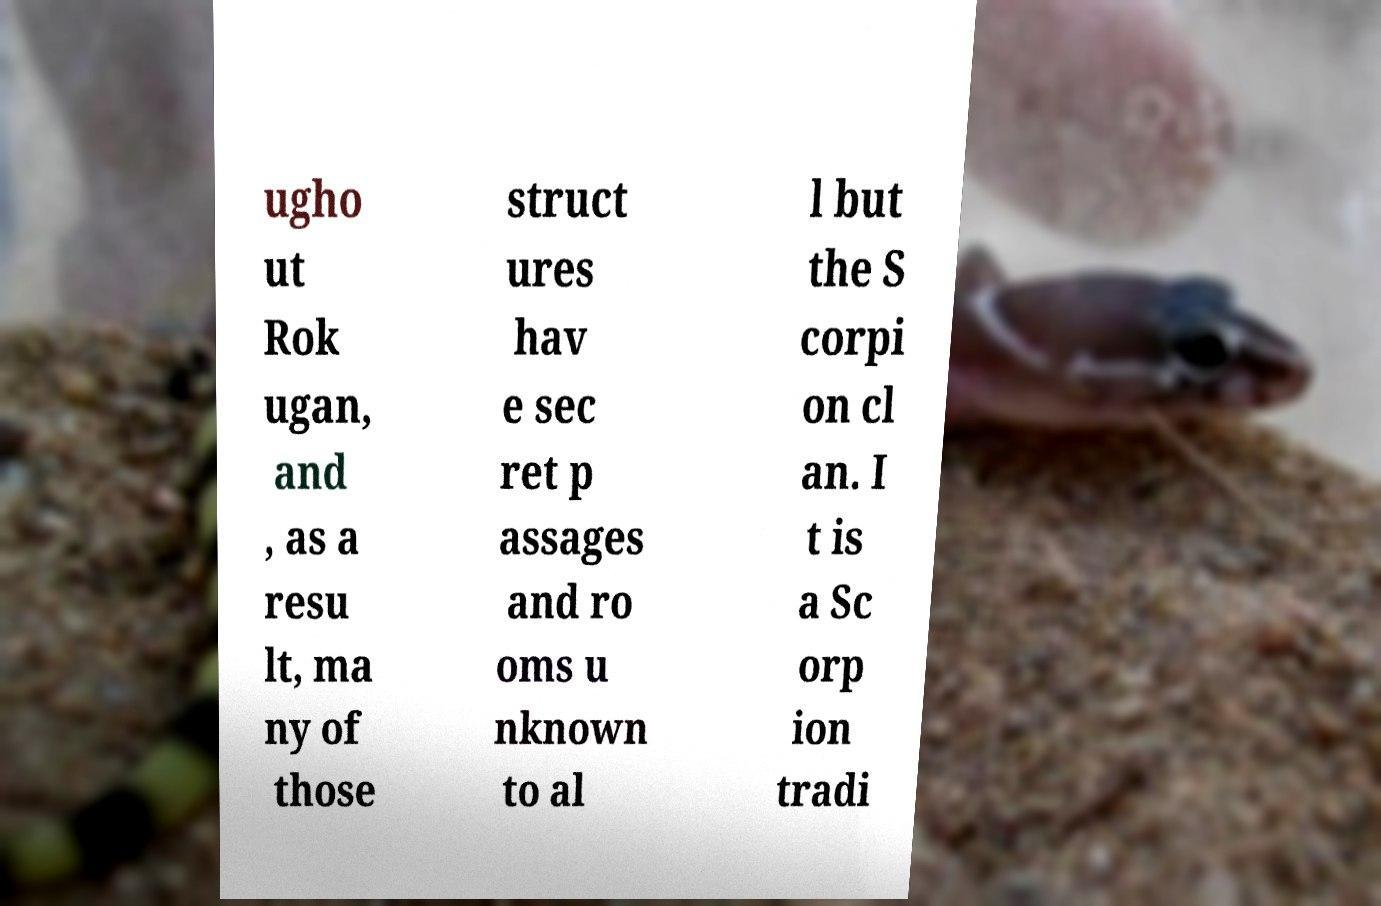Can you read and provide the text displayed in the image?This photo seems to have some interesting text. Can you extract and type it out for me? ugho ut Rok ugan, and , as a resu lt, ma ny of those struct ures hav e sec ret p assages and ro oms u nknown to al l but the S corpi on cl an. I t is a Sc orp ion tradi 